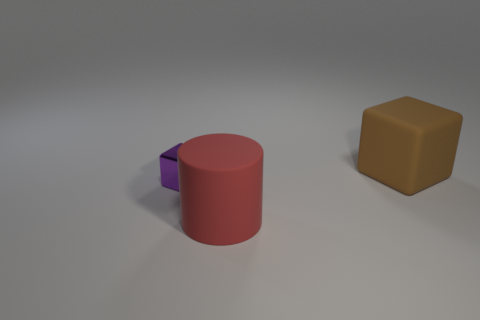Add 3 purple objects. How many objects exist? 6 Subtract 1 cylinders. How many cylinders are left? 0 Add 2 rubber cylinders. How many rubber cylinders are left? 3 Add 3 small cyan cubes. How many small cyan cubes exist? 3 Subtract 1 brown cubes. How many objects are left? 2 Subtract all cubes. How many objects are left? 1 Subtract all green cubes. Subtract all brown balls. How many cubes are left? 2 Subtract all cyan cubes. How many brown cylinders are left? 0 Subtract all small red metal objects. Subtract all purple metal cubes. How many objects are left? 2 